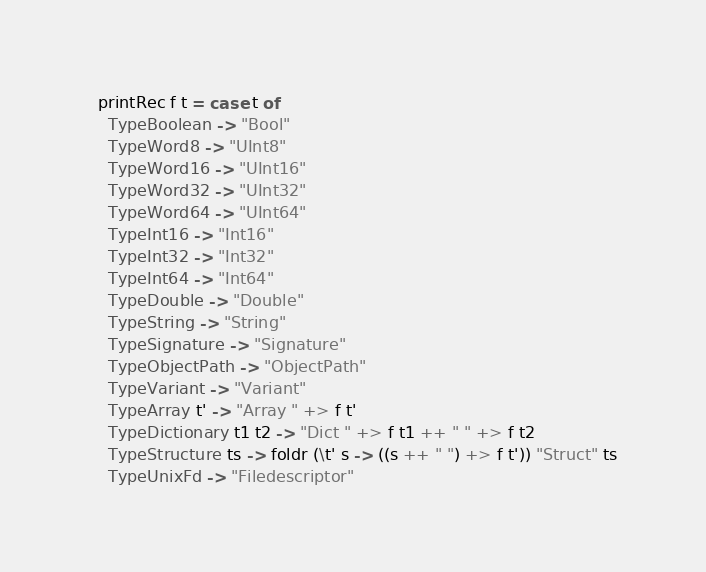<code> <loc_0><loc_0><loc_500><loc_500><_Haskell_>  printRec f t = case t of
    TypeBoolean -> "Bool"
    TypeWord8 -> "UInt8"
    TypeWord16 -> "UInt16"
    TypeWord32 -> "UInt32"
    TypeWord64 -> "UInt64"
    TypeInt16 -> "Int16"
    TypeInt32 -> "Int32"
    TypeInt64 -> "Int64"
    TypeDouble -> "Double"
    TypeString -> "String"
    TypeSignature -> "Signature"
    TypeObjectPath -> "ObjectPath"
    TypeVariant -> "Variant"
    TypeArray t' -> "Array " +> f t'
    TypeDictionary t1 t2 -> "Dict " +> f t1 ++ " " +> f t2
    TypeStructure ts -> foldr (\t' s -> ((s ++ " ") +> f t')) "Struct" ts
    TypeUnixFd -> "Filedescriptor"
</code> 